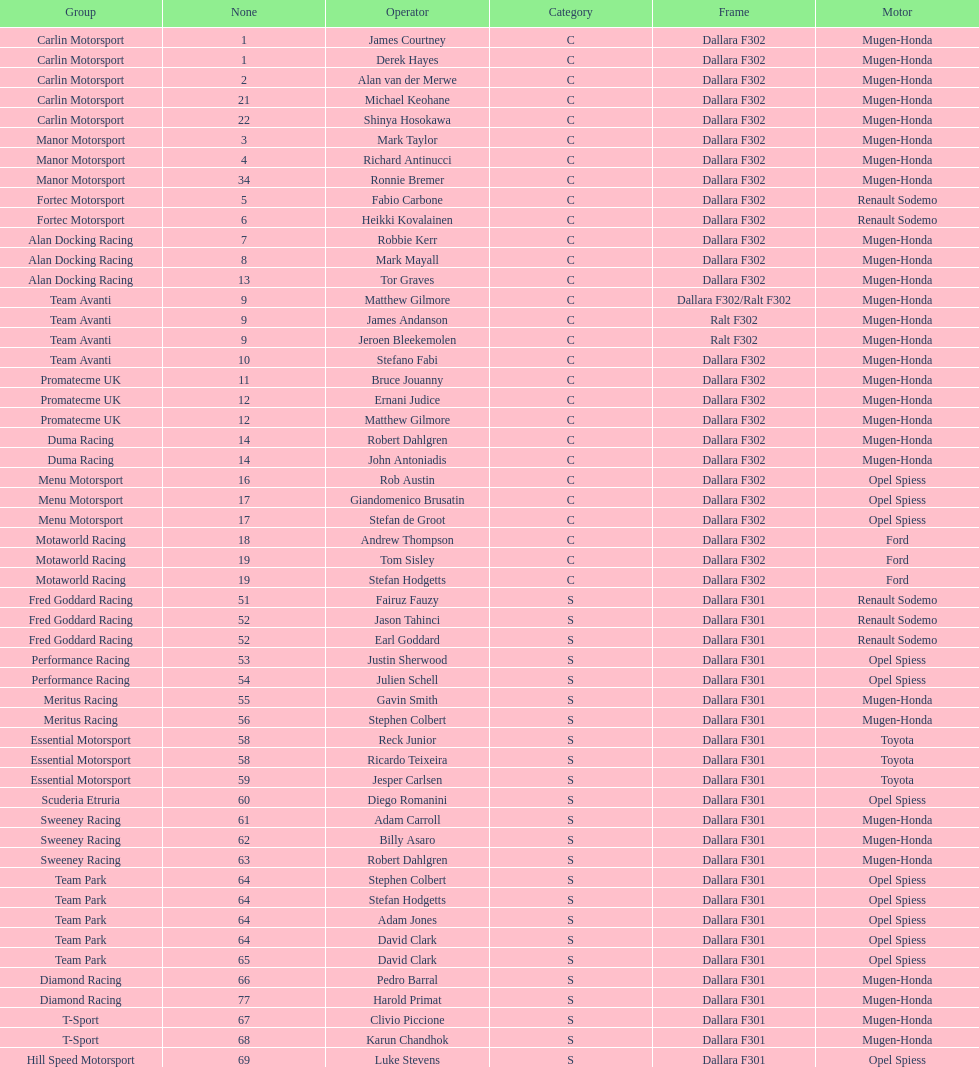The two drivers on t-sport are clivio piccione and what other driver? Karun Chandhok. 